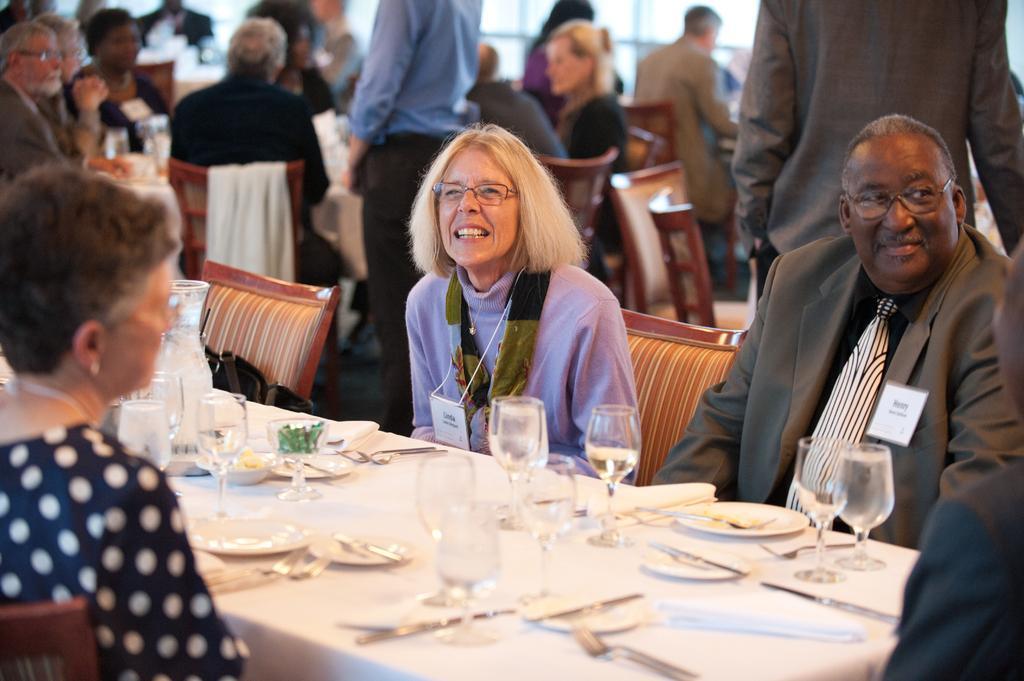Can you describe this image briefly? In this image I can see few people are sitting on the chairs around the table. The table is covered with a white cloth and there are some glasses, plates, spoons are there on it. In the background also there are some tables. 